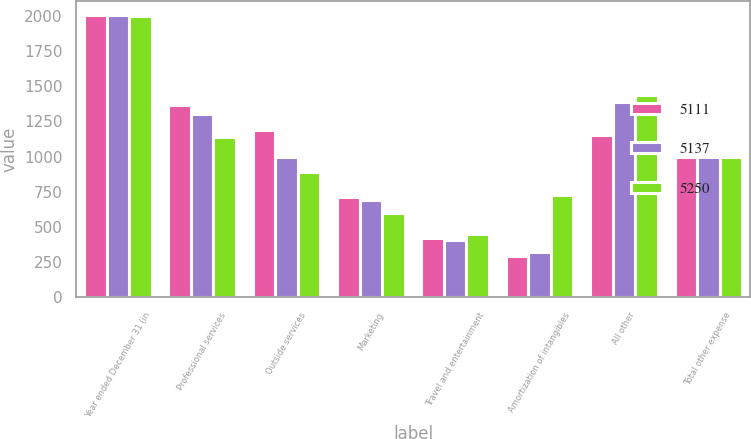Convert chart to OTSL. <chart><loc_0><loc_0><loc_500><loc_500><stacked_bar_chart><ecel><fcel>Year ended December 31 (in<fcel>Professional services<fcel>Outside services<fcel>Marketing<fcel>Travel and entertainment<fcel>Amortization of intangibles<fcel>All other<fcel>Total other expense<nl><fcel>5111<fcel>2003<fcel>1368<fcel>1187<fcel>710<fcel>422<fcel>294<fcel>1156<fcel>994<nl><fcel>5137<fcel>2002<fcel>1303<fcel>994<fcel>689<fcel>411<fcel>323<fcel>1391<fcel>994<nl><fcel>5250<fcel>2001<fcel>1139<fcel>888<fcel>601<fcel>453<fcel>729<fcel>1440<fcel>994<nl></chart> 